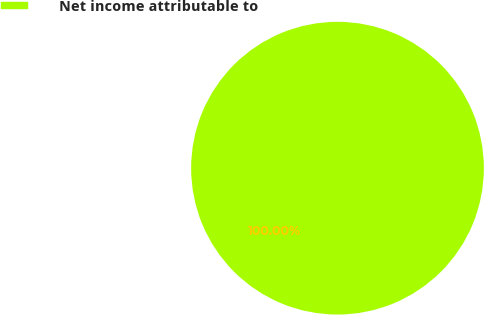<chart> <loc_0><loc_0><loc_500><loc_500><pie_chart><fcel>Net income attributable to<nl><fcel>100.0%<nl></chart> 